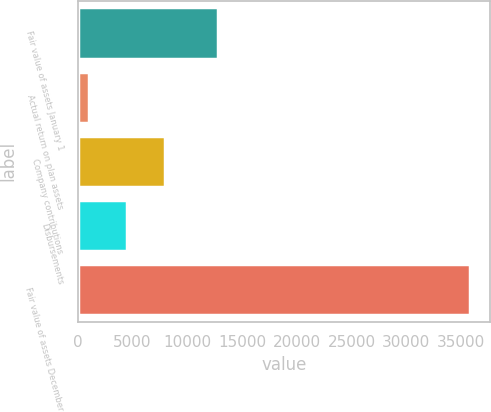<chart> <loc_0><loc_0><loc_500><loc_500><bar_chart><fcel>Fair value of assets January 1<fcel>Actual return on plan assets<fcel>Company contributions<fcel>Disbursements<fcel>Fair value of assets December<nl><fcel>12798<fcel>1007<fcel>7977.4<fcel>4492.2<fcel>35859<nl></chart> 